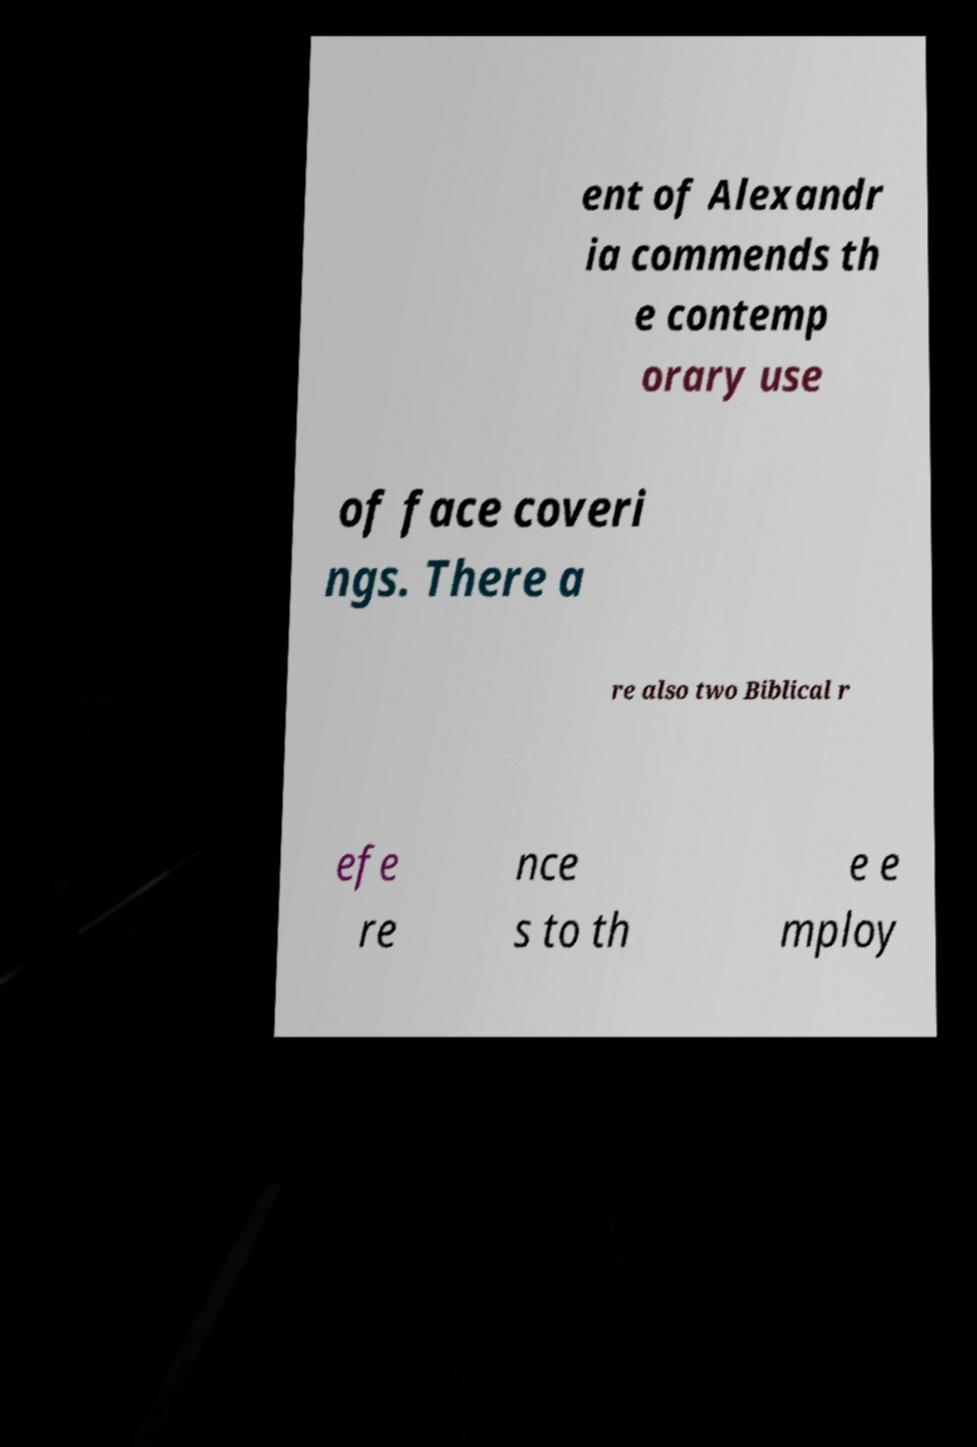There's text embedded in this image that I need extracted. Can you transcribe it verbatim? ent of Alexandr ia commends th e contemp orary use of face coveri ngs. There a re also two Biblical r efe re nce s to th e e mploy 